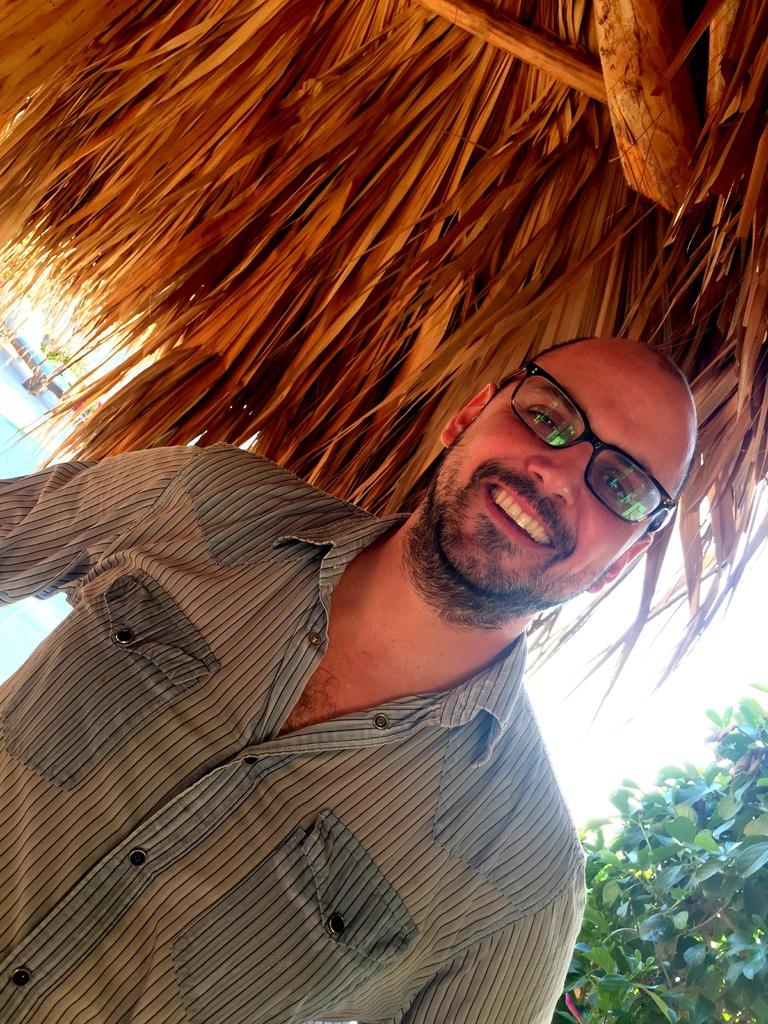Who is present in the image? There is a man in the picture. What is the man doing in the image? The man is smiling. What accessory is the man wearing in the image? The man is wearing spectacles. What can be seen in the background of the image? There are plants in the image. Can you describe the structure in the image? There appears to be a man standing under a hut in the image. How many pens are visible on the table in the image? There is no table or pens present in the image. What time of day is it in the image? The provided facts do not give any information about the time of day in the image. 